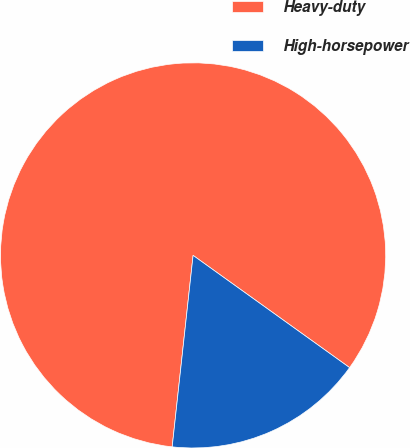Convert chart. <chart><loc_0><loc_0><loc_500><loc_500><pie_chart><fcel>Heavy-duty<fcel>High-horsepower<nl><fcel>83.17%<fcel>16.83%<nl></chart> 